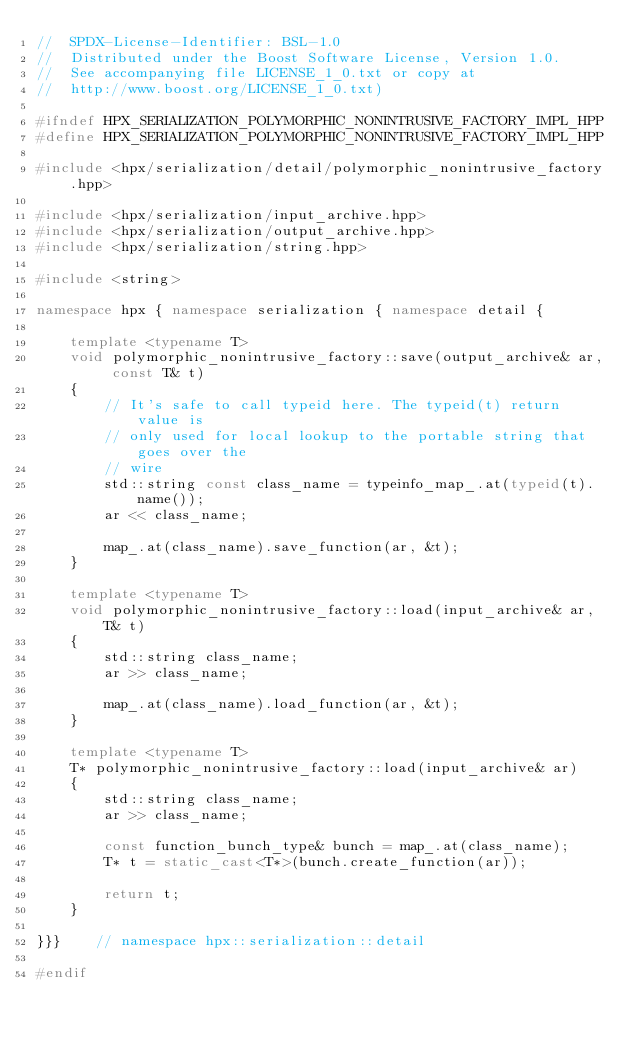<code> <loc_0><loc_0><loc_500><loc_500><_C++_>//  SPDX-License-Identifier: BSL-1.0
//  Distributed under the Boost Software License, Version 1.0.
//  See accompanying file LICENSE_1_0.txt or copy at
//  http://www.boost.org/LICENSE_1_0.txt)

#ifndef HPX_SERIALIZATION_POLYMORPHIC_NONINTRUSIVE_FACTORY_IMPL_HPP
#define HPX_SERIALIZATION_POLYMORPHIC_NONINTRUSIVE_FACTORY_IMPL_HPP

#include <hpx/serialization/detail/polymorphic_nonintrusive_factory.hpp>

#include <hpx/serialization/input_archive.hpp>
#include <hpx/serialization/output_archive.hpp>
#include <hpx/serialization/string.hpp>

#include <string>

namespace hpx { namespace serialization { namespace detail {

    template <typename T>
    void polymorphic_nonintrusive_factory::save(output_archive& ar, const T& t)
    {
        // It's safe to call typeid here. The typeid(t) return value is
        // only used for local lookup to the portable string that goes over the
        // wire
        std::string const class_name = typeinfo_map_.at(typeid(t).name());
        ar << class_name;

        map_.at(class_name).save_function(ar, &t);
    }

    template <typename T>
    void polymorphic_nonintrusive_factory::load(input_archive& ar, T& t)
    {
        std::string class_name;
        ar >> class_name;

        map_.at(class_name).load_function(ar, &t);
    }

    template <typename T>
    T* polymorphic_nonintrusive_factory::load(input_archive& ar)
    {
        std::string class_name;
        ar >> class_name;

        const function_bunch_type& bunch = map_.at(class_name);
        T* t = static_cast<T*>(bunch.create_function(ar));

        return t;
    }

}}}    // namespace hpx::serialization::detail

#endif
</code> 